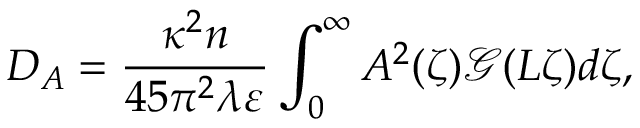Convert formula to latex. <formula><loc_0><loc_0><loc_500><loc_500>D _ { A } = \frac { \kappa ^ { 2 } n } { 4 5 \pi ^ { 2 } \lambda \varepsilon } \int _ { 0 } ^ { \infty } A ^ { 2 } ( \zeta ) \mathcal { G } ( L \zeta ) d \zeta ,</formula> 